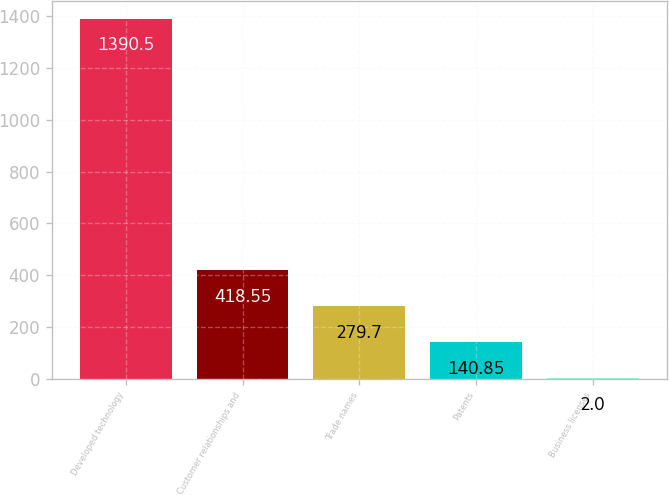Convert chart. <chart><loc_0><loc_0><loc_500><loc_500><bar_chart><fcel>Developed technology<fcel>Customer relationships and<fcel>Trade names<fcel>Patents<fcel>Business licenses<nl><fcel>1390.5<fcel>418.55<fcel>279.7<fcel>140.85<fcel>2<nl></chart> 